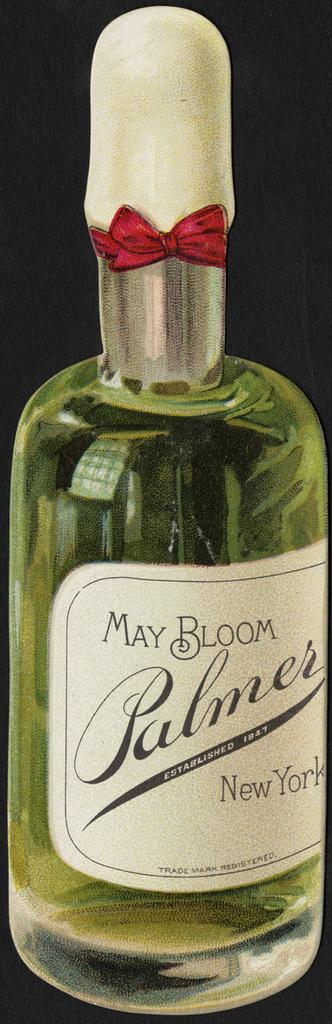What is this liquid called?
Provide a short and direct response. Palmer. Where was this made?
Keep it short and to the point. New york. 